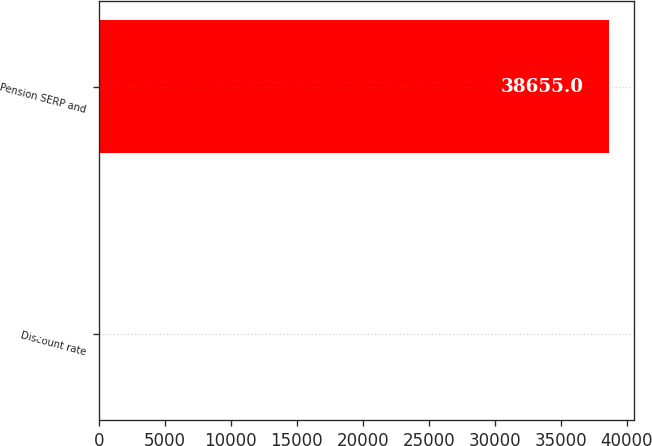Convert chart. <chart><loc_0><loc_0><loc_500><loc_500><bar_chart><fcel>Discount rate<fcel>Pension SERP and<nl><fcel>4.98<fcel>38655<nl></chart> 